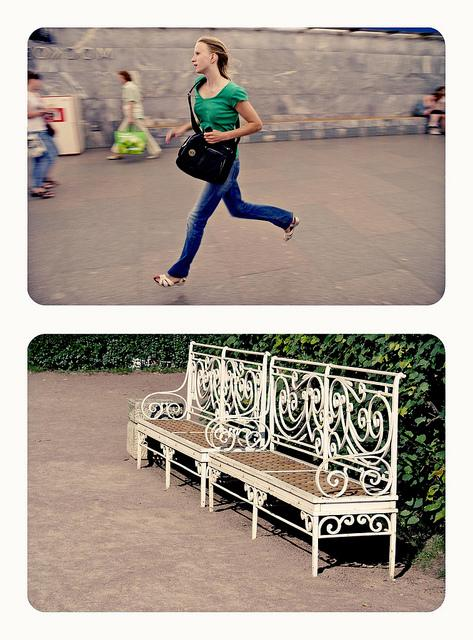Which country invented free public benches?

Choices:
A) belgium
B) france
C) america
D) italy france 